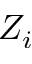Convert formula to latex. <formula><loc_0><loc_0><loc_500><loc_500>Z _ { i }</formula> 